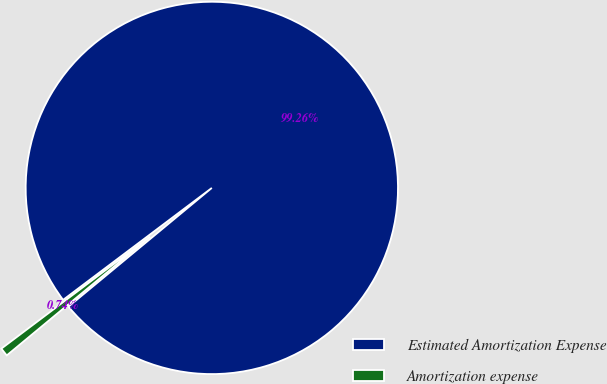Convert chart to OTSL. <chart><loc_0><loc_0><loc_500><loc_500><pie_chart><fcel>Estimated Amortization Expense<fcel>Amortization expense<nl><fcel>99.26%<fcel>0.74%<nl></chart> 